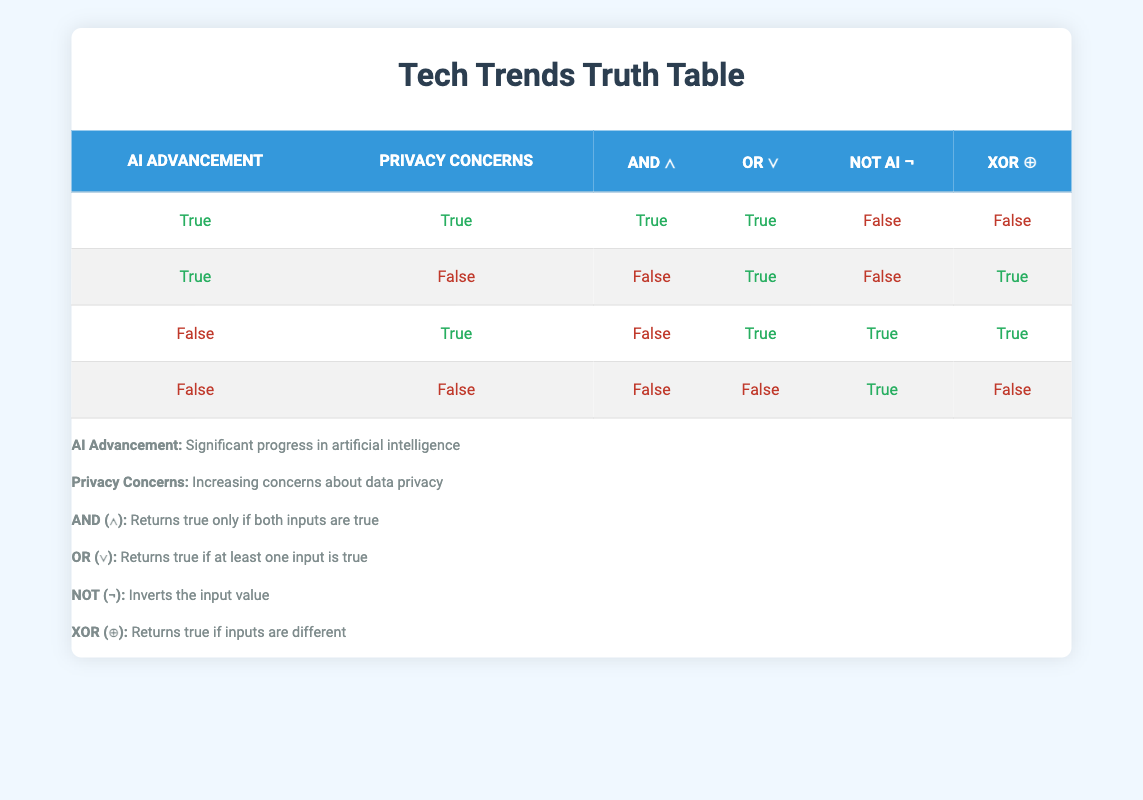What is the truth value when both AI advancement and privacy concerns are true using AND? In the first row of the table, both "AI advancement" and "privacy concerns" are marked as true. According to the definition of AND, the result will also be true when both inputs are true.
Answer: True What is the value of AI advancement OR privacy concerns when AI advancement is false and privacy concerns are true? In the third row, "AI advancement" is false and "privacy concerns" is true. With the OR operator, if at least one of the inputs is true, the outcome will also be true. Hence, the value is true.
Answer: True What is the value of NOT AI advancement when AI advancement is true? The NOT operator inverts the input value. Here, "AI advancement" is true, so NOT will result in false. This is observed in the first and second rows where AI advancement is true and NOT AI advancement is false.
Answer: False How many scenarios yield true values in the XOR operation? The XOR operator returns true when the inputs are different. From the table, it can be seen that the XOR results in true in the second (true, false) and third (false, true) rows, totaling two scenarios with a true outcome.
Answer: 2 Is the statement "If AI advancement is false then privacy concerns must be true" always correct according to the table? This statement refers to the fourth row where both are false and does not hold true, as a situation exists where AI advancement is false, but privacy concerns are still true (third row). Therefore, it is not always correct.
Answer: No What is the truth value when both conditions (AI advancement and privacy concerns) are false using the AND operator? According to the fourth row, both "AI advancement" and "privacy concerns" are false. The AND operator requires both inputs to be true for a true output, resulting in false in this case.
Answer: False What is the overall result of AI advancement OR privacy concerns when both are false? Following the fourth row, both variables result in false for the OR operation. Since neither is true, the total output will also be false. The logic of OR dictates at least one input must be true for a true outcome.
Answer: False 